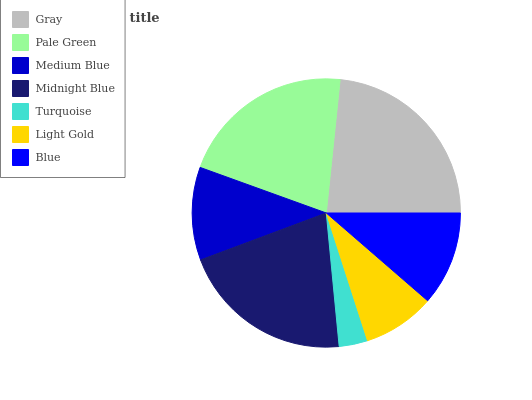Is Turquoise the minimum?
Answer yes or no. Yes. Is Gray the maximum?
Answer yes or no. Yes. Is Pale Green the minimum?
Answer yes or no. No. Is Pale Green the maximum?
Answer yes or no. No. Is Gray greater than Pale Green?
Answer yes or no. Yes. Is Pale Green less than Gray?
Answer yes or no. Yes. Is Pale Green greater than Gray?
Answer yes or no. No. Is Gray less than Pale Green?
Answer yes or no. No. Is Blue the high median?
Answer yes or no. Yes. Is Blue the low median?
Answer yes or no. Yes. Is Gray the high median?
Answer yes or no. No. Is Gray the low median?
Answer yes or no. No. 